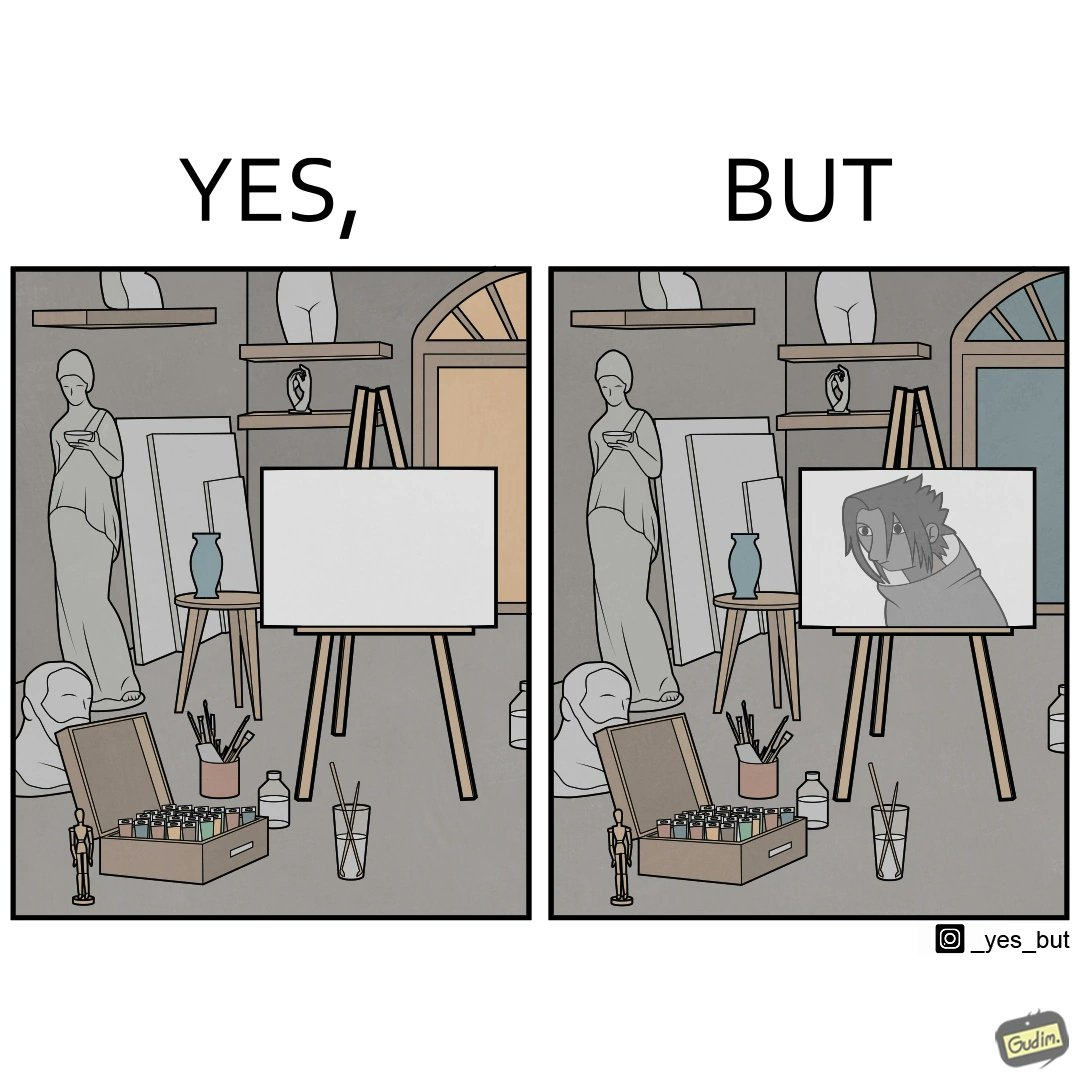What is shown in this image? The image is ironical, as even though the art studio contains a palette of a range of color paints, the painting on the canvas is black and white. 